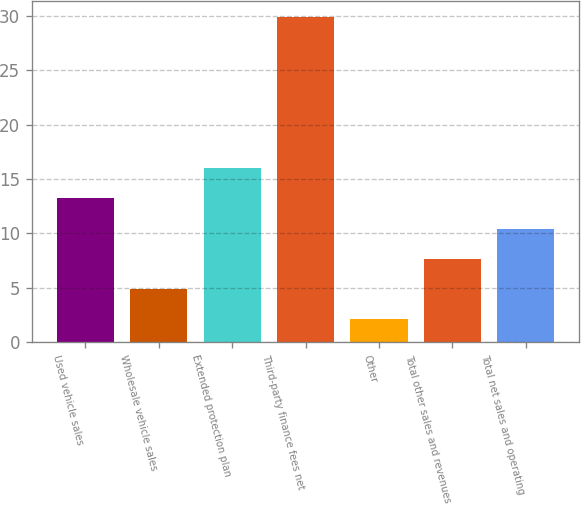<chart> <loc_0><loc_0><loc_500><loc_500><bar_chart><fcel>Used vehicle sales<fcel>Wholesale vehicle sales<fcel>Extended protection plan<fcel>Third-party finance fees net<fcel>Other<fcel>Total other sales and revenues<fcel>Total net sales and operating<nl><fcel>13.22<fcel>4.88<fcel>16<fcel>29.9<fcel>2.1<fcel>7.66<fcel>10.44<nl></chart> 